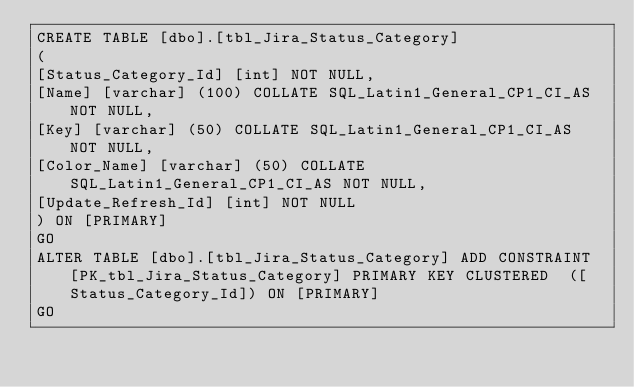Convert code to text. <code><loc_0><loc_0><loc_500><loc_500><_SQL_>CREATE TABLE [dbo].[tbl_Jira_Status_Category]
(
[Status_Category_Id] [int] NOT NULL,
[Name] [varchar] (100) COLLATE SQL_Latin1_General_CP1_CI_AS NOT NULL,
[Key] [varchar] (50) COLLATE SQL_Latin1_General_CP1_CI_AS NOT NULL,
[Color_Name] [varchar] (50) COLLATE SQL_Latin1_General_CP1_CI_AS NOT NULL,
[Update_Refresh_Id] [int] NOT NULL
) ON [PRIMARY]
GO
ALTER TABLE [dbo].[tbl_Jira_Status_Category] ADD CONSTRAINT [PK_tbl_Jira_Status_Category] PRIMARY KEY CLUSTERED  ([Status_Category_Id]) ON [PRIMARY]
GO
</code> 